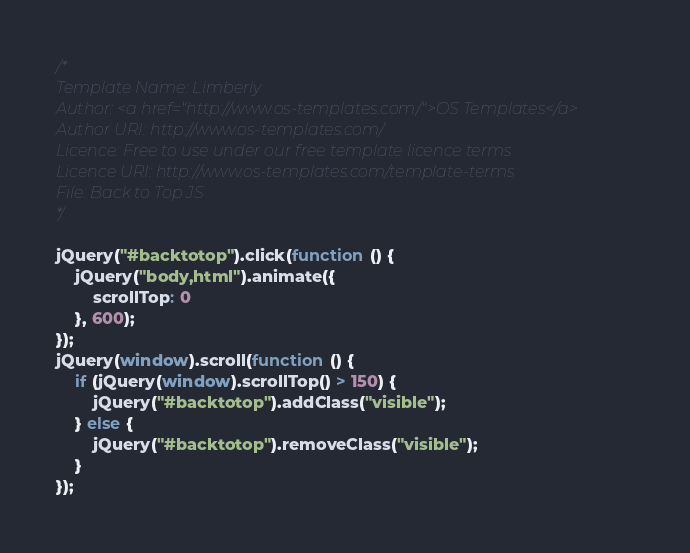<code> <loc_0><loc_0><loc_500><loc_500><_JavaScript_>/*
Template Name: Limberly
Author: <a href="http://www.os-templates.com/">OS Templates</a>
Author URI: http://www.os-templates.com/
Licence: Free to use under our free template licence terms
Licence URI: http://www.os-templates.com/template-terms
File: Back to Top JS
*/

jQuery("#backtotop").click(function () {
    jQuery("body,html").animate({
        scrollTop: 0
    }, 600);
});
jQuery(window).scroll(function () {
    if (jQuery(window).scrollTop() > 150) {
        jQuery("#backtotop").addClass("visible");
    } else {
        jQuery("#backtotop").removeClass("visible");
    }
});</code> 